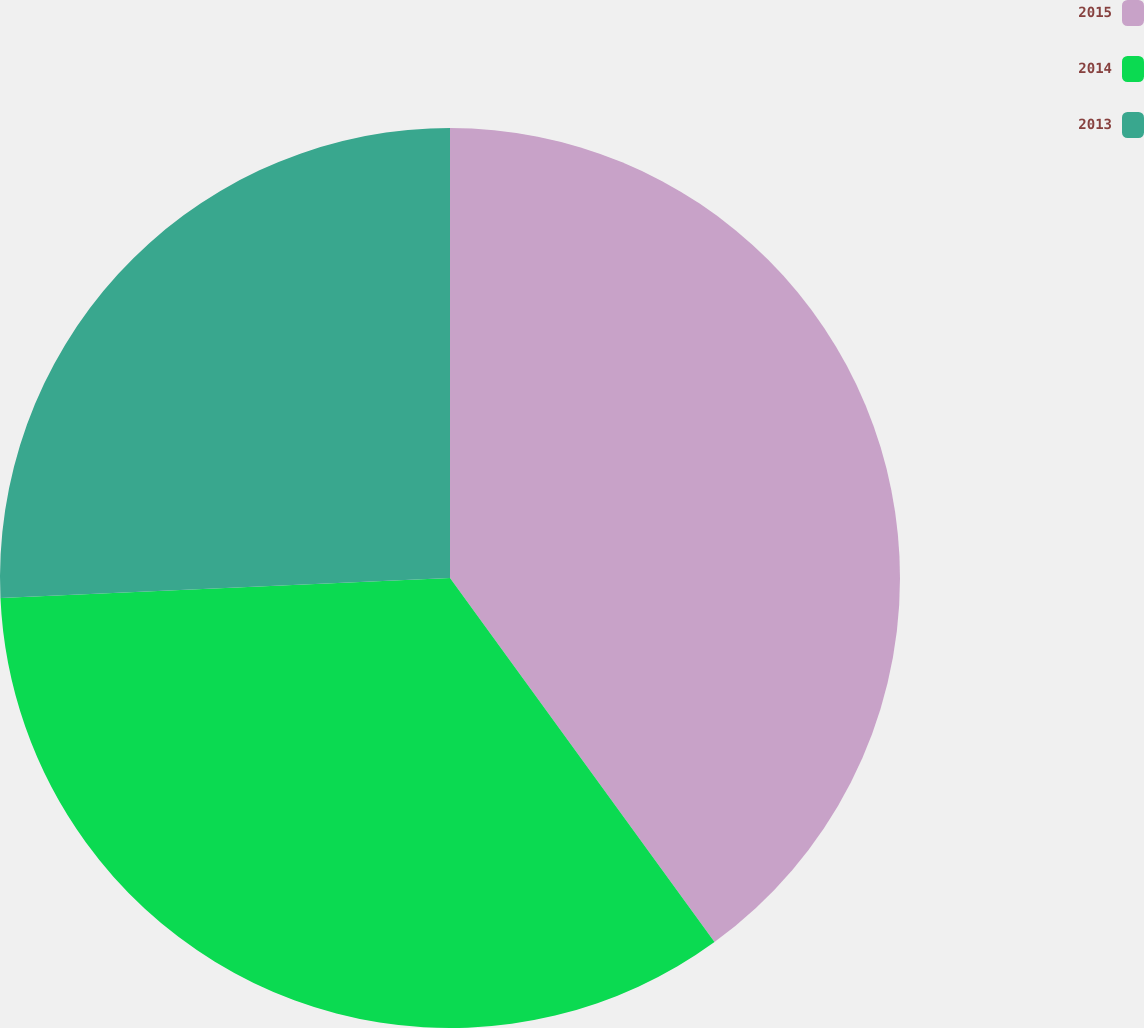<chart> <loc_0><loc_0><loc_500><loc_500><pie_chart><fcel>2015<fcel>2014<fcel>2013<nl><fcel>40.0%<fcel>34.29%<fcel>25.71%<nl></chart> 